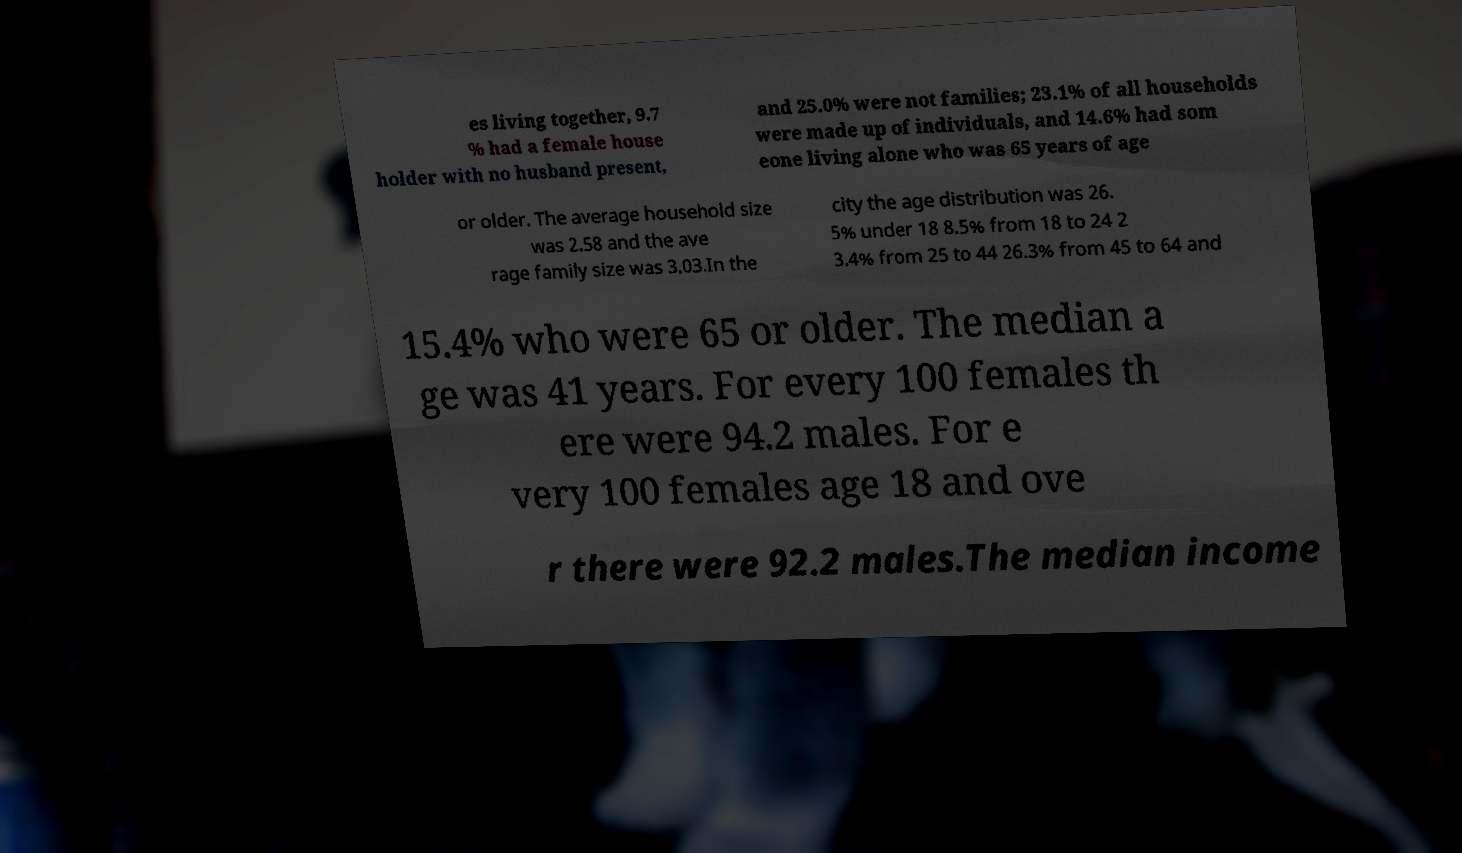For documentation purposes, I need the text within this image transcribed. Could you provide that? es living together, 9.7 % had a female house holder with no husband present, and 25.0% were not families; 23.1% of all households were made up of individuals, and 14.6% had som eone living alone who was 65 years of age or older. The average household size was 2.58 and the ave rage family size was 3.03.In the city the age distribution was 26. 5% under 18 8.5% from 18 to 24 2 3.4% from 25 to 44 26.3% from 45 to 64 and 15.4% who were 65 or older. The median a ge was 41 years. For every 100 females th ere were 94.2 males. For e very 100 females age 18 and ove r there were 92.2 males.The median income 